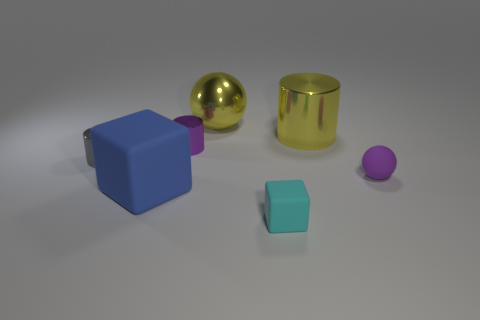Subtract all tiny purple cylinders. How many cylinders are left? 2 Add 2 large blue blocks. How many objects exist? 9 Subtract all gray cylinders. How many cylinders are left? 2 Add 1 small purple matte spheres. How many small purple matte spheres exist? 2 Subtract 1 yellow spheres. How many objects are left? 6 Subtract all balls. How many objects are left? 5 Subtract all blue cylinders. Subtract all brown cubes. How many cylinders are left? 3 Subtract all large yellow shiny cylinders. Subtract all matte things. How many objects are left? 3 Add 3 tiny rubber blocks. How many tiny rubber blocks are left? 4 